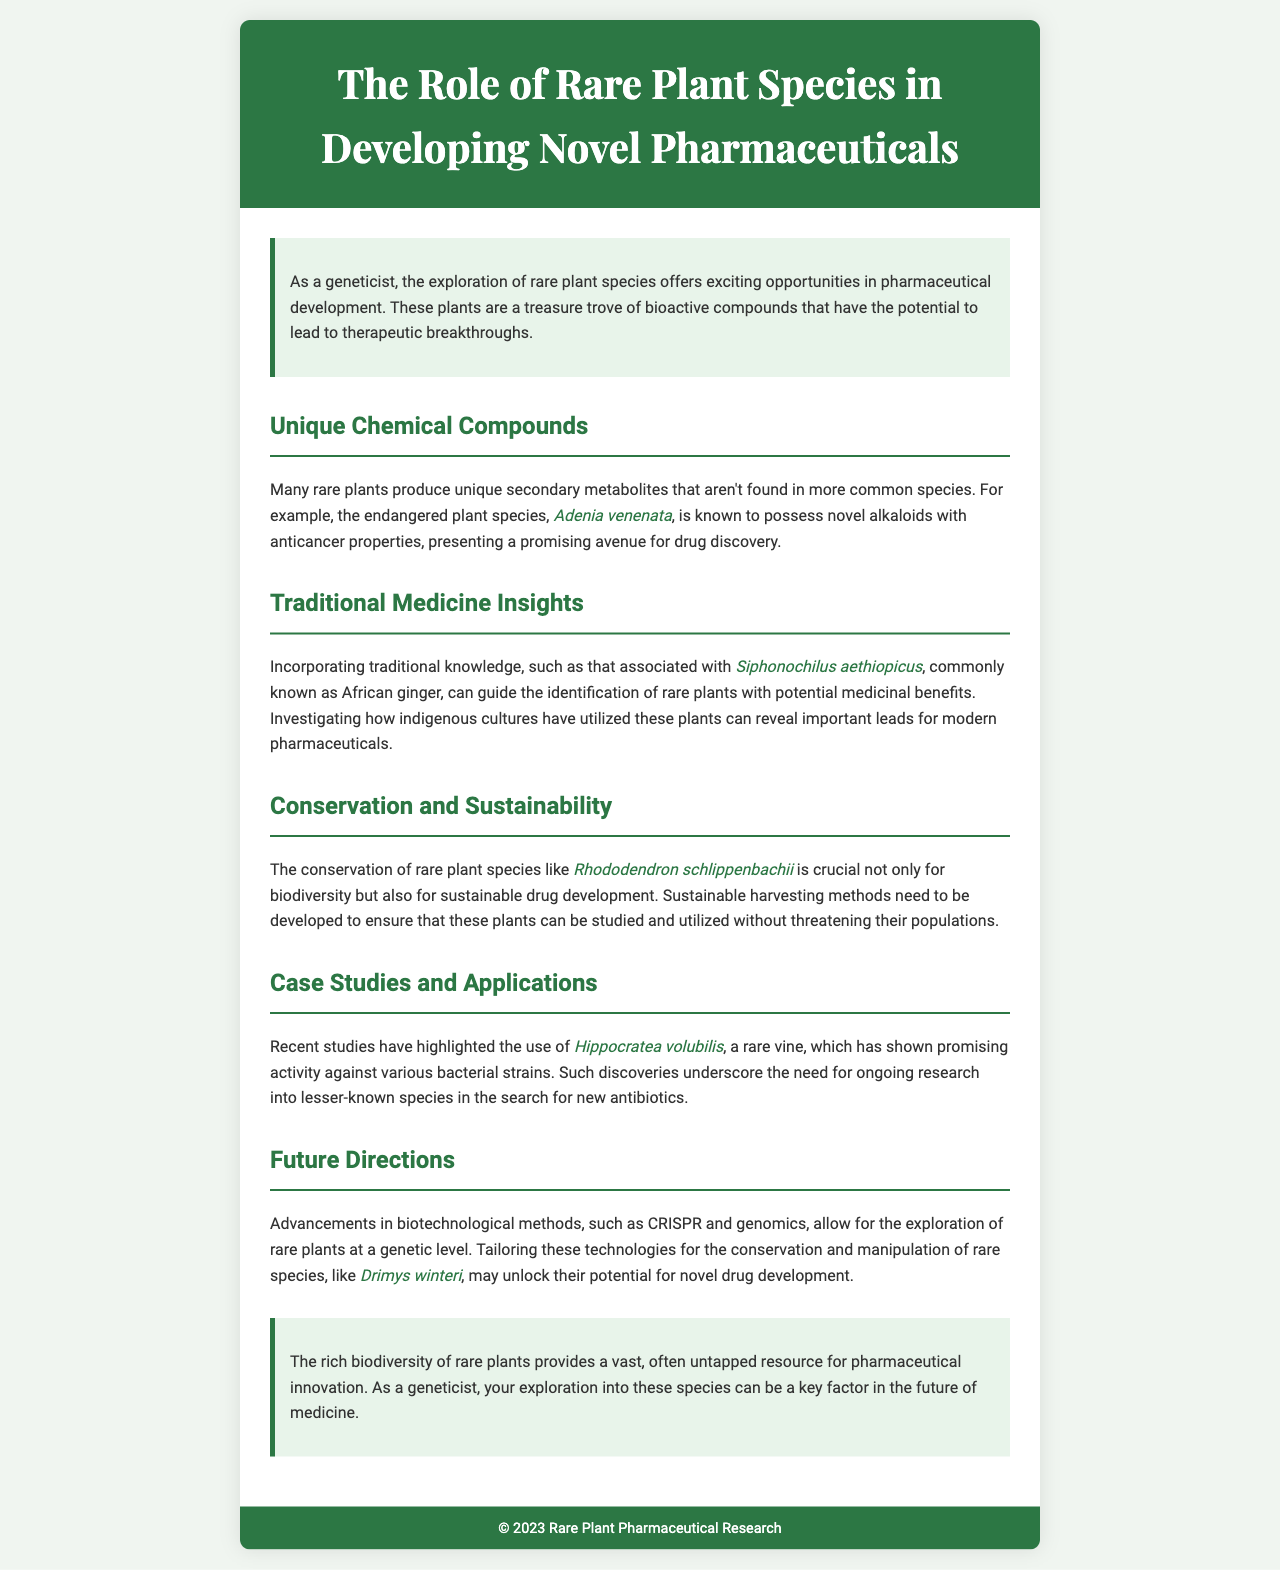What is the title of the brochure? The title of the brochure is prominently displayed in the header section.
Answer: The Role of Rare Plant Species in Developing Novel Pharmaceuticals What is a key benefit of rare plants mentioned in the introduction? The introduction describes rare plants as a treasure trove of bioactive compounds that hold potential in pharmaceutical development.
Answer: Therapeutic breakthroughs Which rare plant is mentioned for its anticancer properties? The document specifies one particular rare plant with anticancer properties in the section about unique chemical compounds.
Answer: Adenia venenata What traditional plant is associated with insights into traditional medicine? The section on traditional medicine discusses a specific plant known for its medicinal benefits based on traditional knowledge.
Answer: Siphonochilus aethiopicus Why is the conservation of rare plants important? The section on conservation emphasizes reasons for preserving rare plant species, which relate to biodiversity and drug development.
Answer: Biodiversity What recent application of a rare plant is highlighted for antibiotic activity? The case studies section provides examples of specific plants showing activity against bacterial strains.
Answer: Hippocratea volubilis Which biotechnological methods are mentioned for exploring rare plants? The future directions section mentions specific technological advancements relevant to the genetic study of rare plants.
Answer: CRISPR and genomics Which rare plant species is highlighted for its conservation and manipulation potential? In the future directions section, a specific rare plant is named that may be explored for drug development.
Answer: Drimys winteri What color theme is used in the brochure? The overall color scheme and style can be inferred from the CSS and the document appearance.
Answer: Green and white 